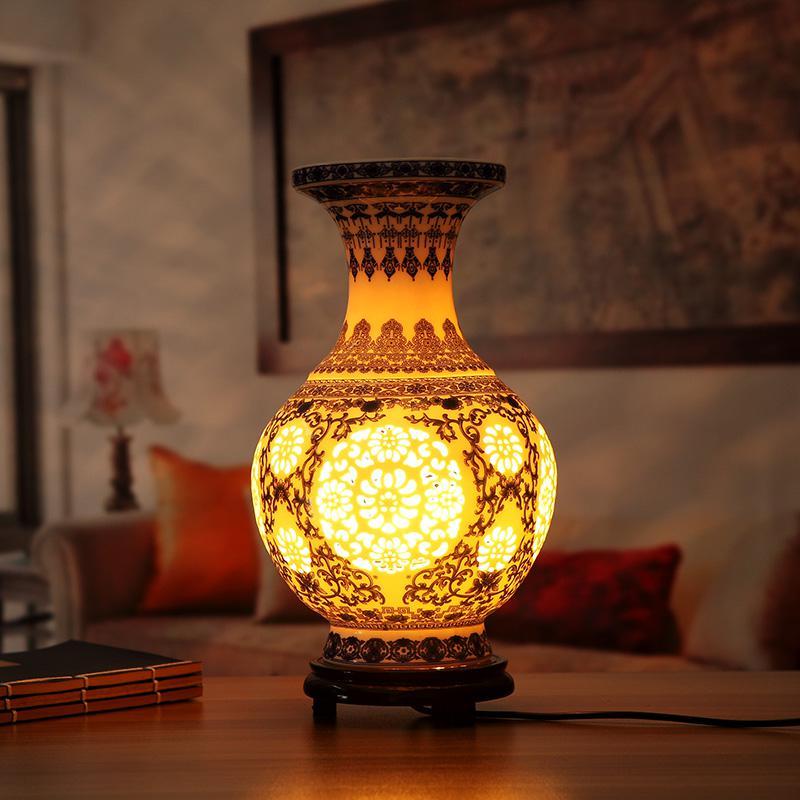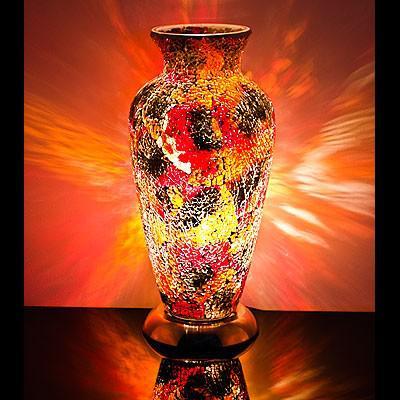The first image is the image on the left, the second image is the image on the right. Given the left and right images, does the statement "Both vases share the same shape." hold true? Answer yes or no. No. 